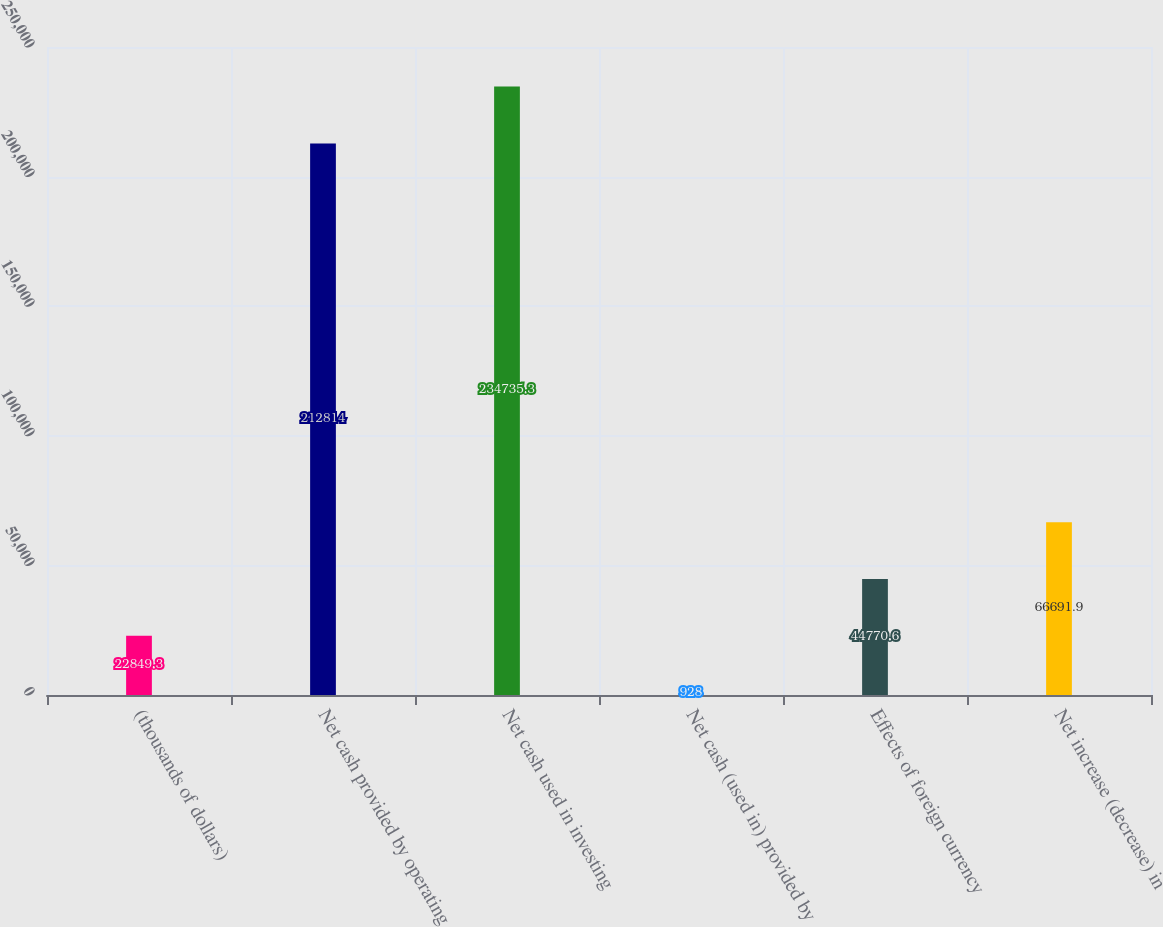<chart> <loc_0><loc_0><loc_500><loc_500><bar_chart><fcel>(thousands of dollars)<fcel>Net cash provided by operating<fcel>Net cash used in investing<fcel>Net cash (used in) provided by<fcel>Effects of foreign currency<fcel>Net increase (decrease) in<nl><fcel>22849.3<fcel>212814<fcel>234735<fcel>928<fcel>44770.6<fcel>66691.9<nl></chart> 